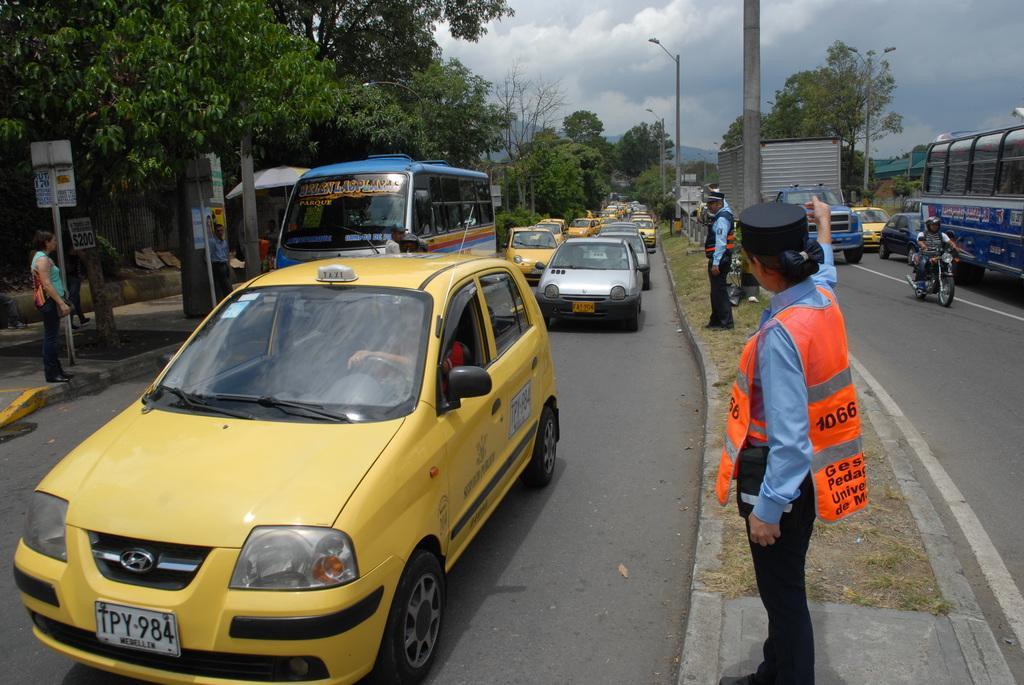In one or two sentences, can you explain what this image depicts? In this image, there are a few people and vehicles. We can see the ground and some grass. There are a few poles and trees. We can also see an umbrella and some boards with text. We can see some hills and posters. We can see the sky with clouds. 